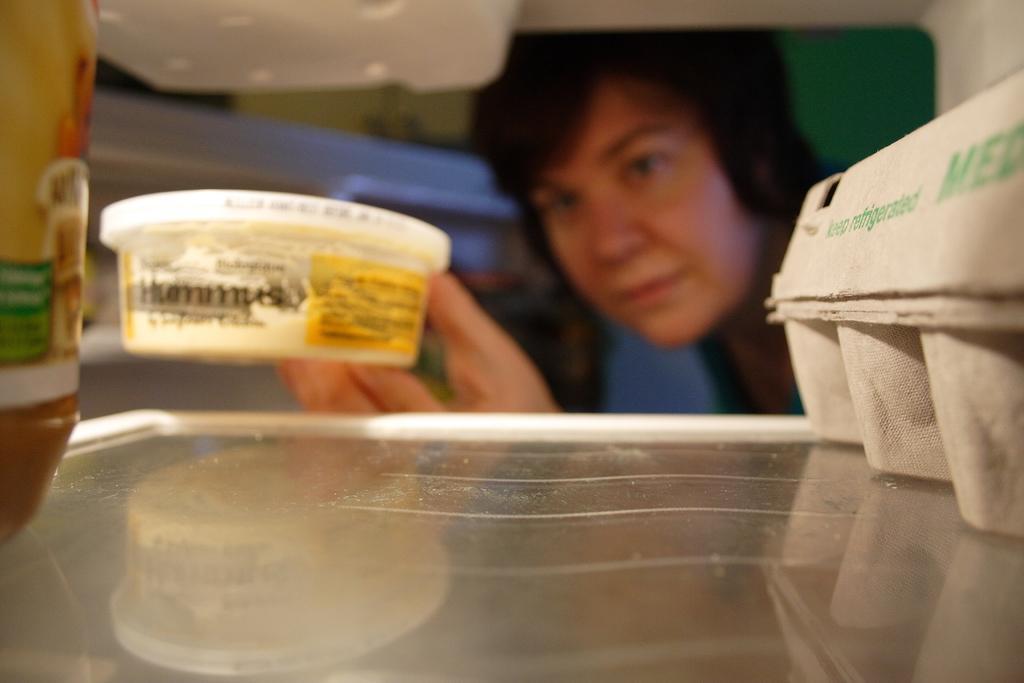Could you give a brief overview of what you see in this image? In this image we can see the inside of the refrigerator, one man near the refrigerator holding a one box, some objects in the refrigerator and one green object on the backside of the person looks like a wall. 